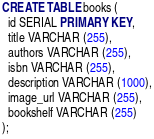<code> <loc_0><loc_0><loc_500><loc_500><_SQL_>
CREATE TABLE books (
  id SERIAL PRIMARY KEY, 
  title VARCHAR (255),
  authors VARCHAR (255),
  isbn VARCHAR (255),
  description VARCHAR (1000),
  image_url VARCHAR (255),
  bookshelf VARCHAR (255)
);</code> 